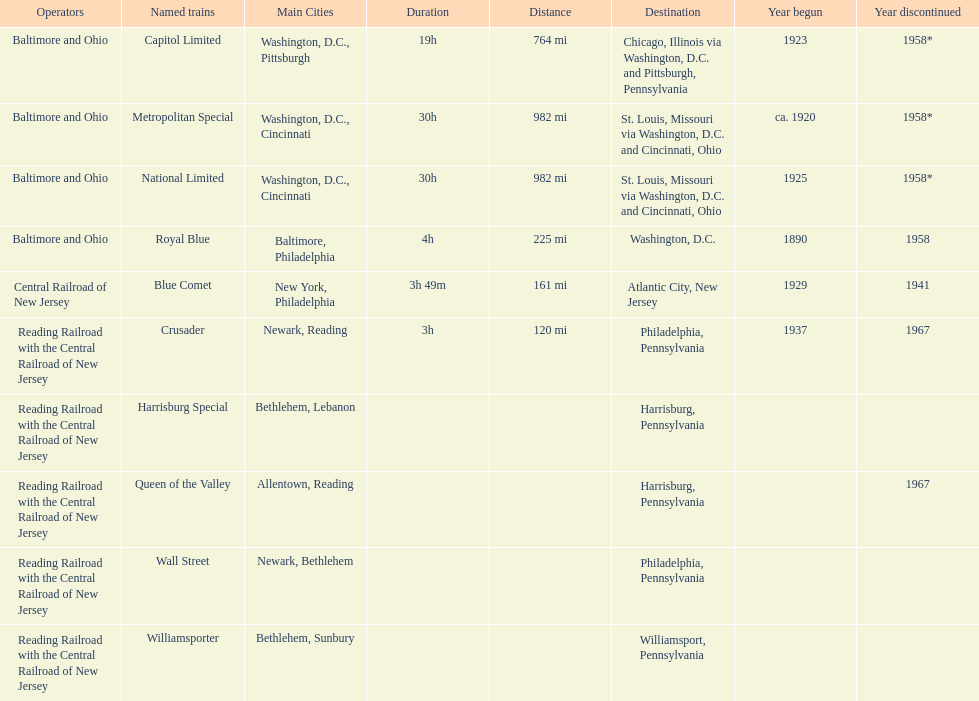What is the sum of all years that have initiated? 6. 